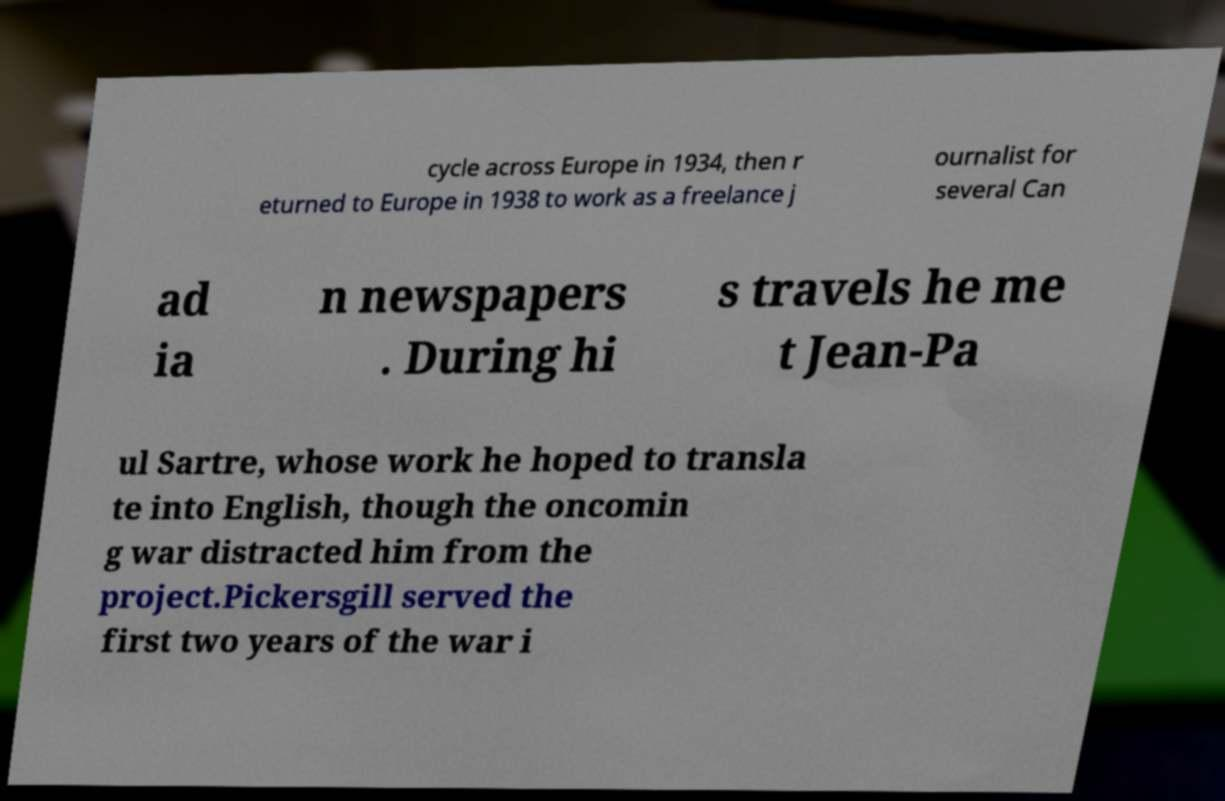For documentation purposes, I need the text within this image transcribed. Could you provide that? cycle across Europe in 1934, then r eturned to Europe in 1938 to work as a freelance j ournalist for several Can ad ia n newspapers . During hi s travels he me t Jean-Pa ul Sartre, whose work he hoped to transla te into English, though the oncomin g war distracted him from the project.Pickersgill served the first two years of the war i 